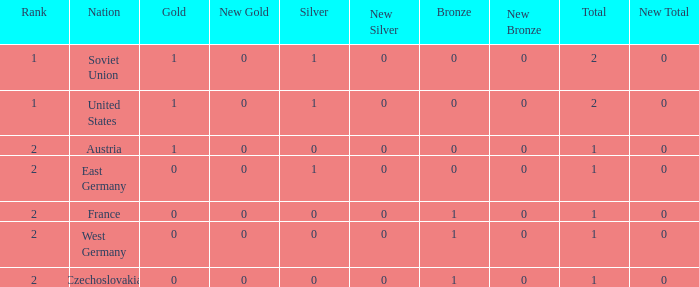What is the rank of the team with 0 gold and less than 0 silvers? None. 